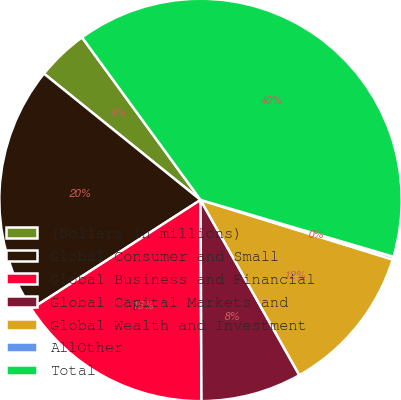<chart> <loc_0><loc_0><loc_500><loc_500><pie_chart><fcel>(Dollars in millions)<fcel>Global Consumer and Small<fcel>Global Business and Financial<fcel>Global Capital Markets and<fcel>Global Wealth and Investment<fcel>AllOther<fcel>Total<nl><fcel>4.17%<fcel>19.91%<fcel>15.97%<fcel>8.1%<fcel>12.04%<fcel>0.23%<fcel>39.58%<nl></chart> 